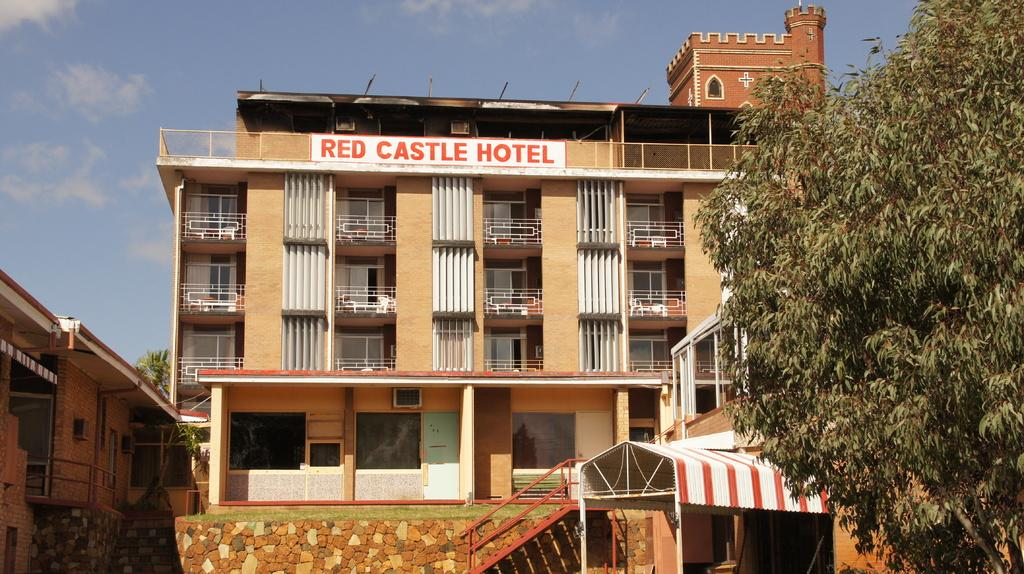What type of structures are located at the bottom of the image? There are buildings at the bottom of the image. What can be seen on the right side of the image? There is a tree on the right side of the image. What is visible in the background of the image? The sky is visible in the background of the image. How many sisters are sitting under the tree in the image? There are no sisters present in the image; it only features buildings, a tree, and the sky. What type of glue is being used by the laborer in the image? There is no laborer or glue present in the image. 